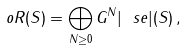Convert formula to latex. <formula><loc_0><loc_0><loc_500><loc_500>o R ( S ) = \bigoplus _ { N \geq 0 } G ^ { N } | \ s e | ( S ) \, ,</formula> 